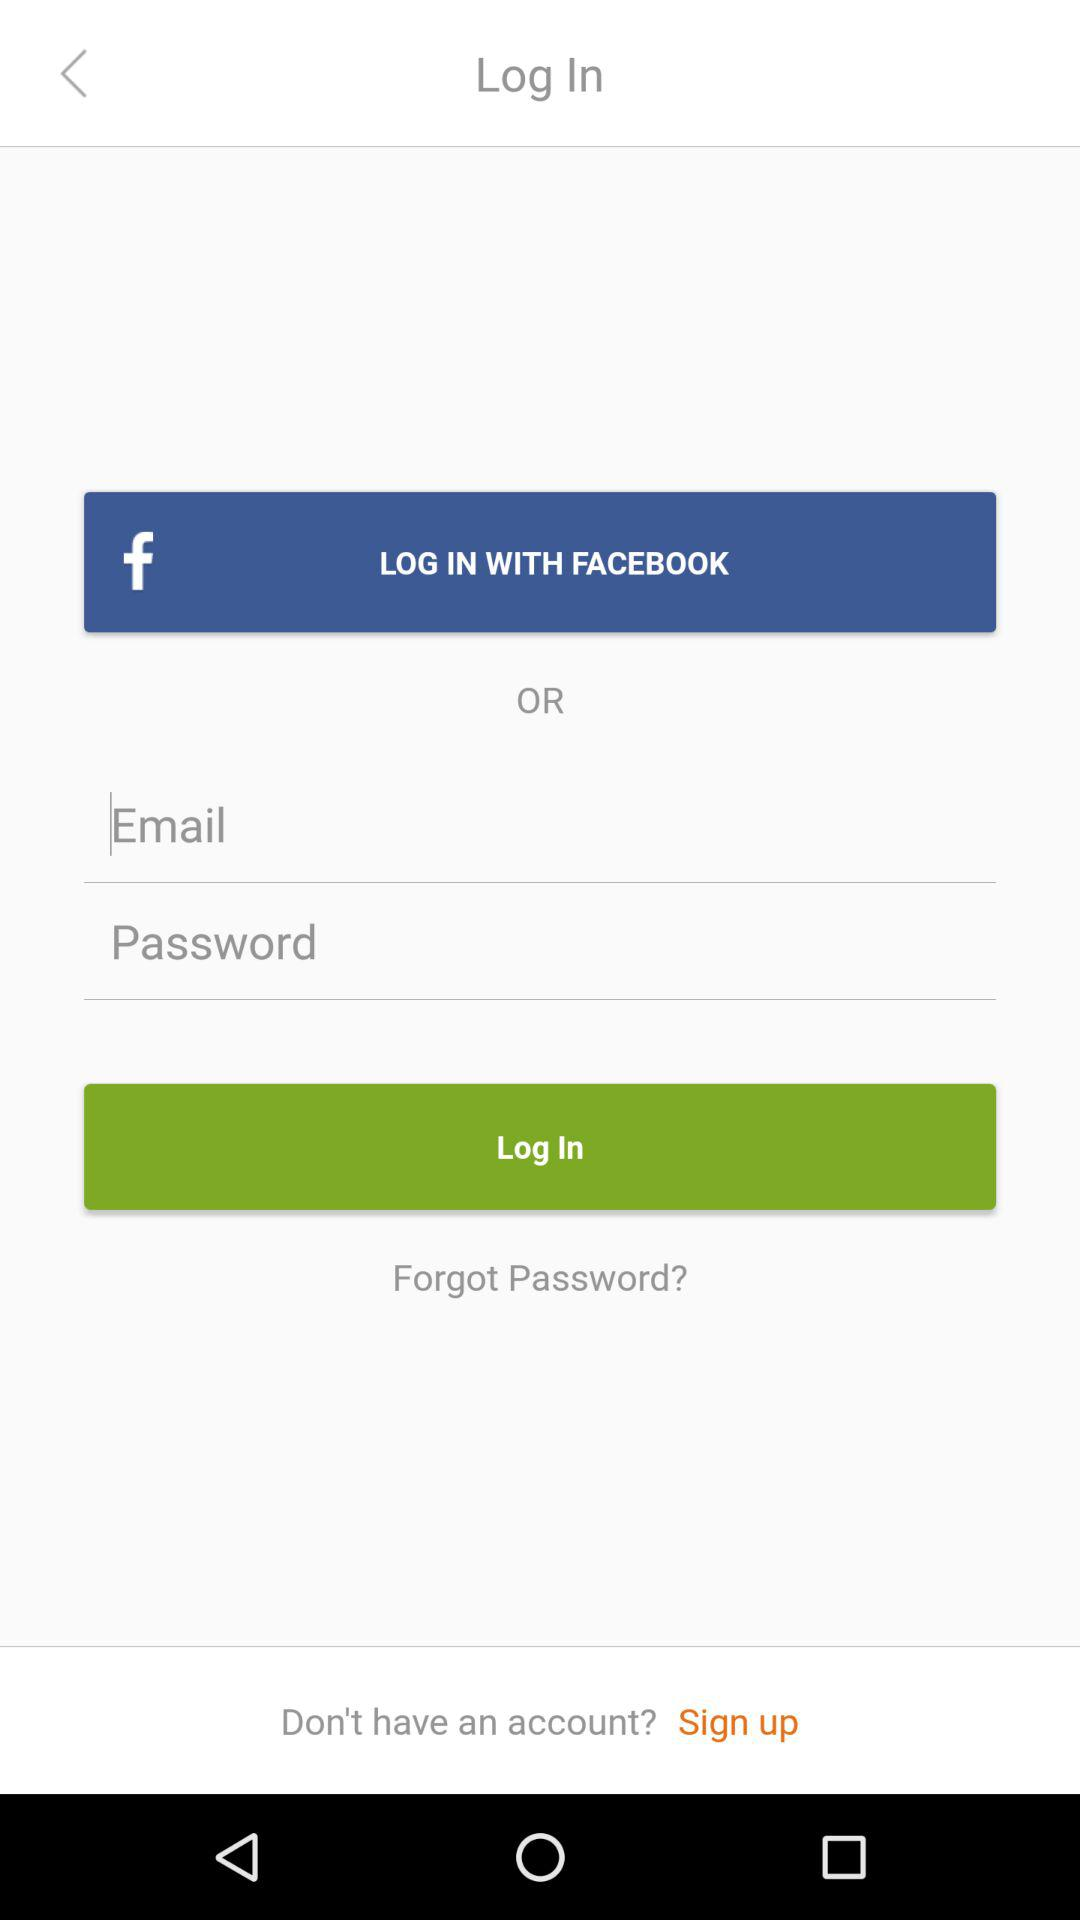Through what application can we log in? You can log in through "FACEBOOK". 